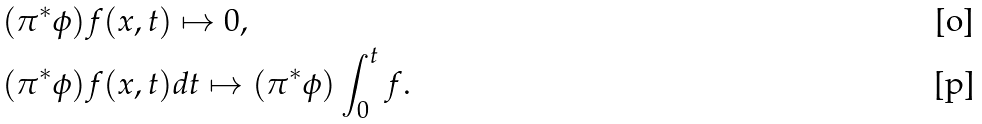Convert formula to latex. <formula><loc_0><loc_0><loc_500><loc_500>& ( \pi ^ { * } \phi ) f ( x , t ) \mapsto 0 , \\ & ( \pi ^ { * } \phi ) f ( x , t ) d t \mapsto ( \pi ^ { * } \phi ) \int _ { 0 } ^ { t } f .</formula> 